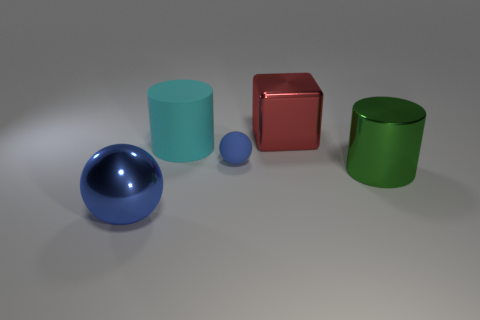Add 1 brown metallic cubes. How many objects exist? 6 Subtract all cylinders. How many objects are left? 3 Subtract all tiny blue objects. Subtract all cylinders. How many objects are left? 2 Add 5 small blue spheres. How many small blue spheres are left? 6 Add 3 large blue metallic spheres. How many large blue metallic spheres exist? 4 Subtract 0 green blocks. How many objects are left? 5 